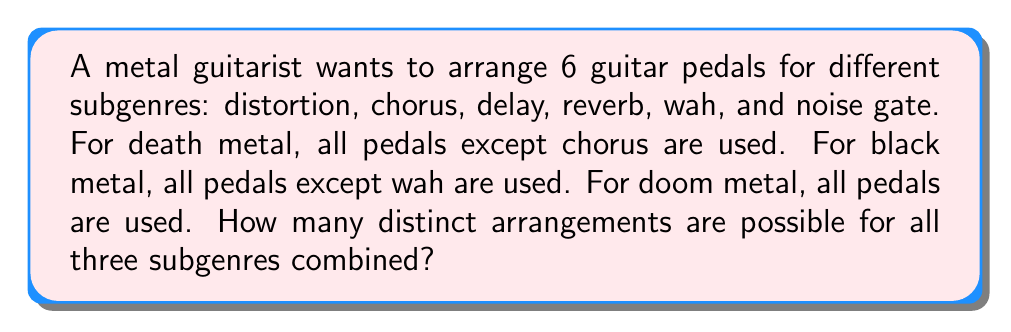Help me with this question. Let's break this down step-by-step:

1. For death metal:
   - 5 pedals are used (all except chorus)
   - Number of arrangements = $5! = 5 \times 4 \times 3 \times 2 \times 1 = 120$

2. For black metal:
   - 5 pedals are used (all except wah)
   - Number of arrangements = $5! = 5 \times 4 \times 3 \times 2 \times 1 = 120$

3. For doom metal:
   - All 6 pedals are used
   - Number of arrangements = $6! = 6 \times 5 \times 4 \times 3 \times 2 \times 1 = 720$

4. Total number of distinct arrangements:
   - We sum up the arrangements for each subgenre
   - Total = Death metal + Black metal + Doom metal
   - Total = $120 + 120 + 720 = 960$

Therefore, the total number of distinct arrangements for all three subgenres combined is 960.
Answer: 960 